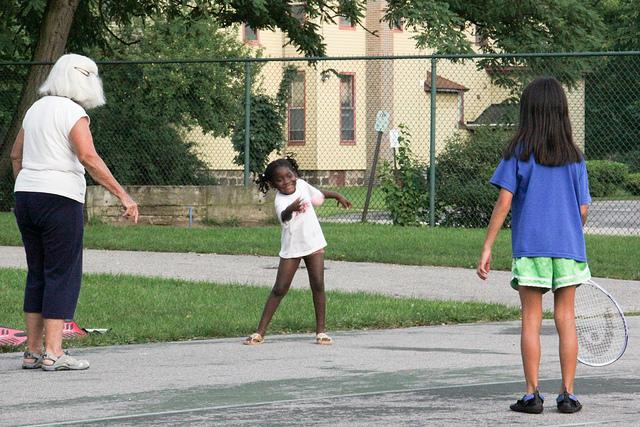What type of sporting area are girls most likely playing on? Please explain your reasoning. tennis court. The girls are playing on a tennis court. 